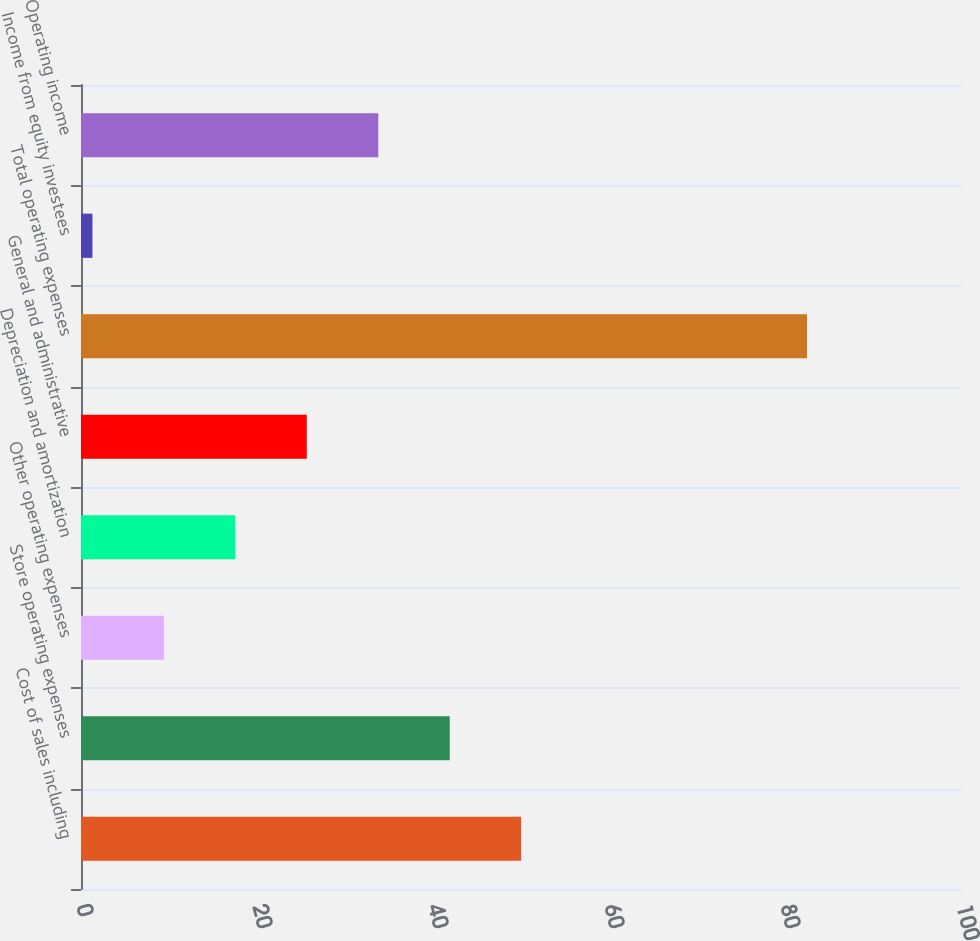Convert chart. <chart><loc_0><loc_0><loc_500><loc_500><bar_chart><fcel>Cost of sales including<fcel>Store operating expenses<fcel>Other operating expenses<fcel>Depreciation and amortization<fcel>General and administrative<fcel>Total operating expenses<fcel>Income from equity investees<fcel>Operating income<nl><fcel>50.02<fcel>41.9<fcel>9.42<fcel>17.54<fcel>25.66<fcel>82.5<fcel>1.3<fcel>33.78<nl></chart> 